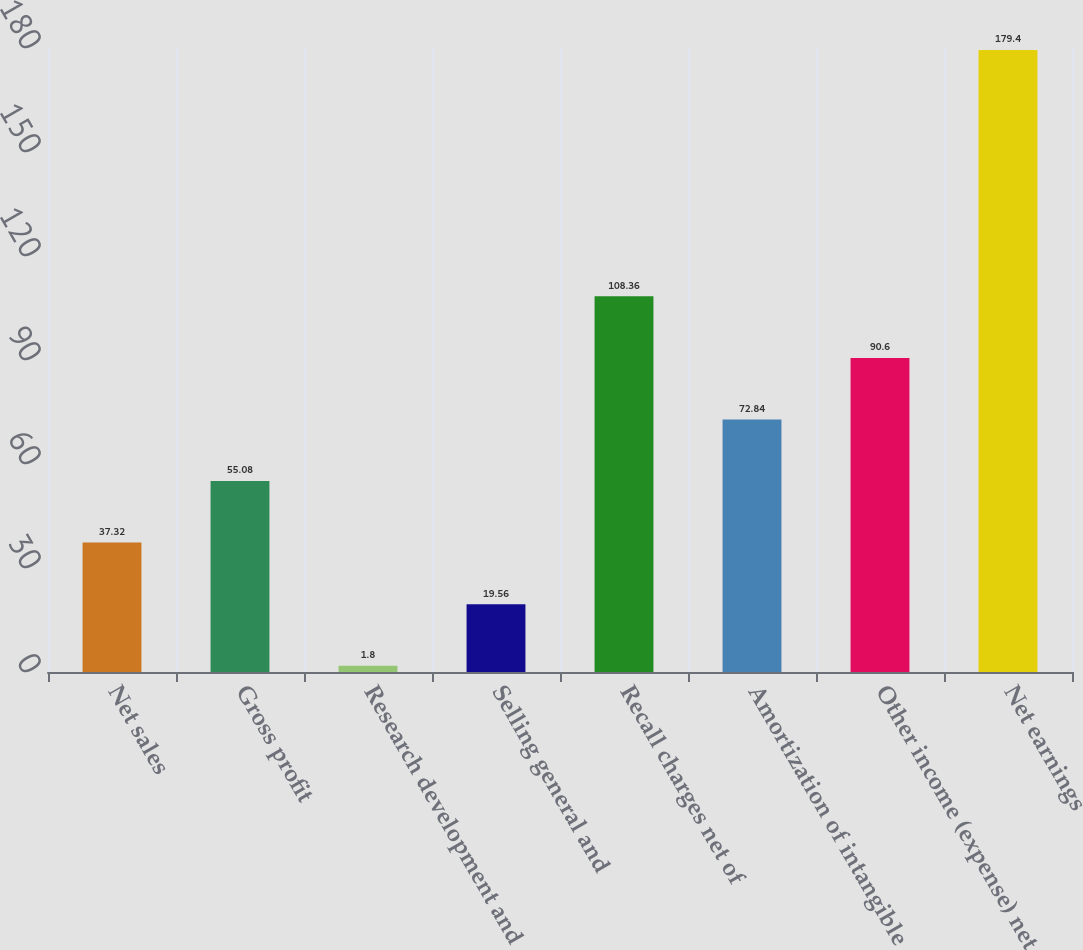Convert chart to OTSL. <chart><loc_0><loc_0><loc_500><loc_500><bar_chart><fcel>Net sales<fcel>Gross profit<fcel>Research development and<fcel>Selling general and<fcel>Recall charges net of<fcel>Amortization of intangible<fcel>Other income (expense) net<fcel>Net earnings<nl><fcel>37.32<fcel>55.08<fcel>1.8<fcel>19.56<fcel>108.36<fcel>72.84<fcel>90.6<fcel>179.4<nl></chart> 